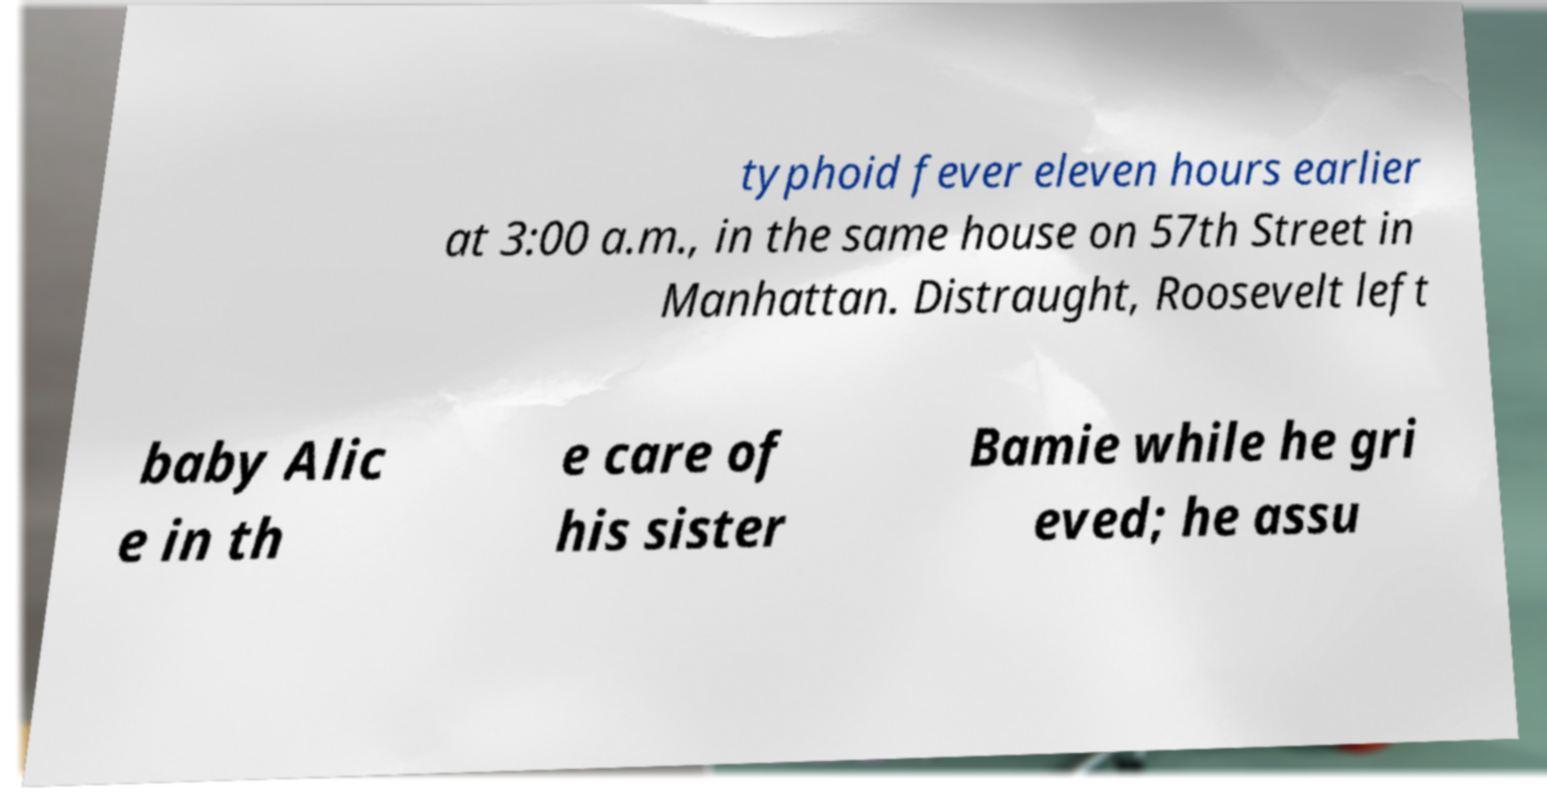Could you assist in decoding the text presented in this image and type it out clearly? typhoid fever eleven hours earlier at 3:00 a.m., in the same house on 57th Street in Manhattan. Distraught, Roosevelt left baby Alic e in th e care of his sister Bamie while he gri eved; he assu 